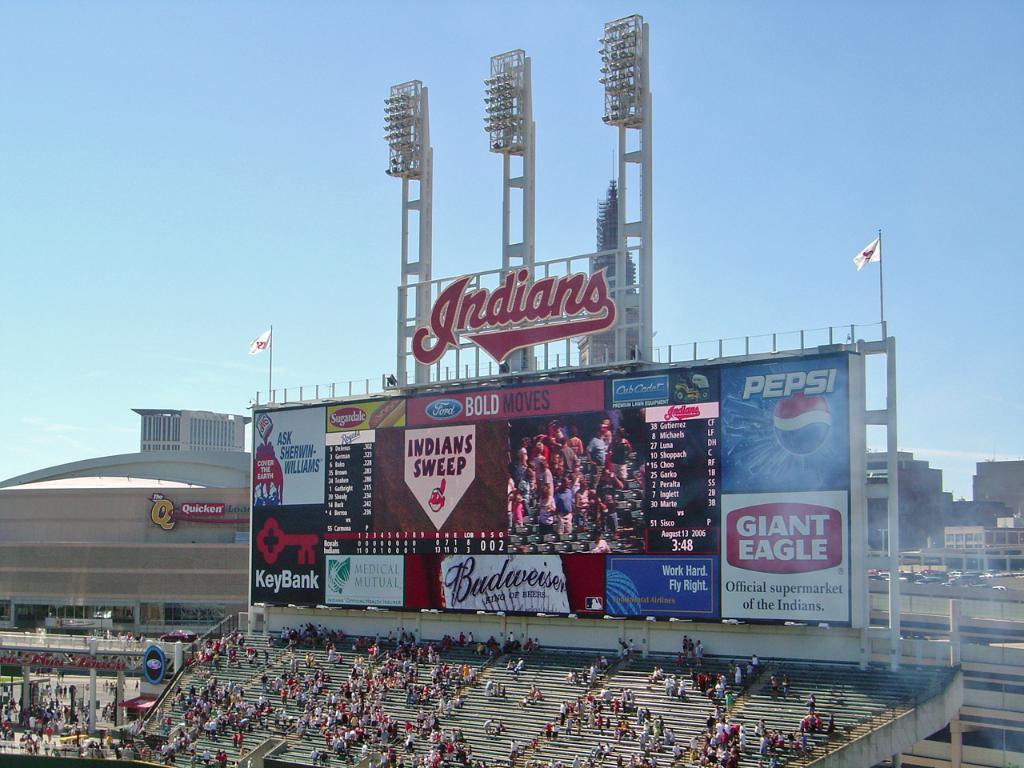<image>
Share a concise interpretation of the image provided. A stadium for the Indians sponsored by Giant Eagle. 